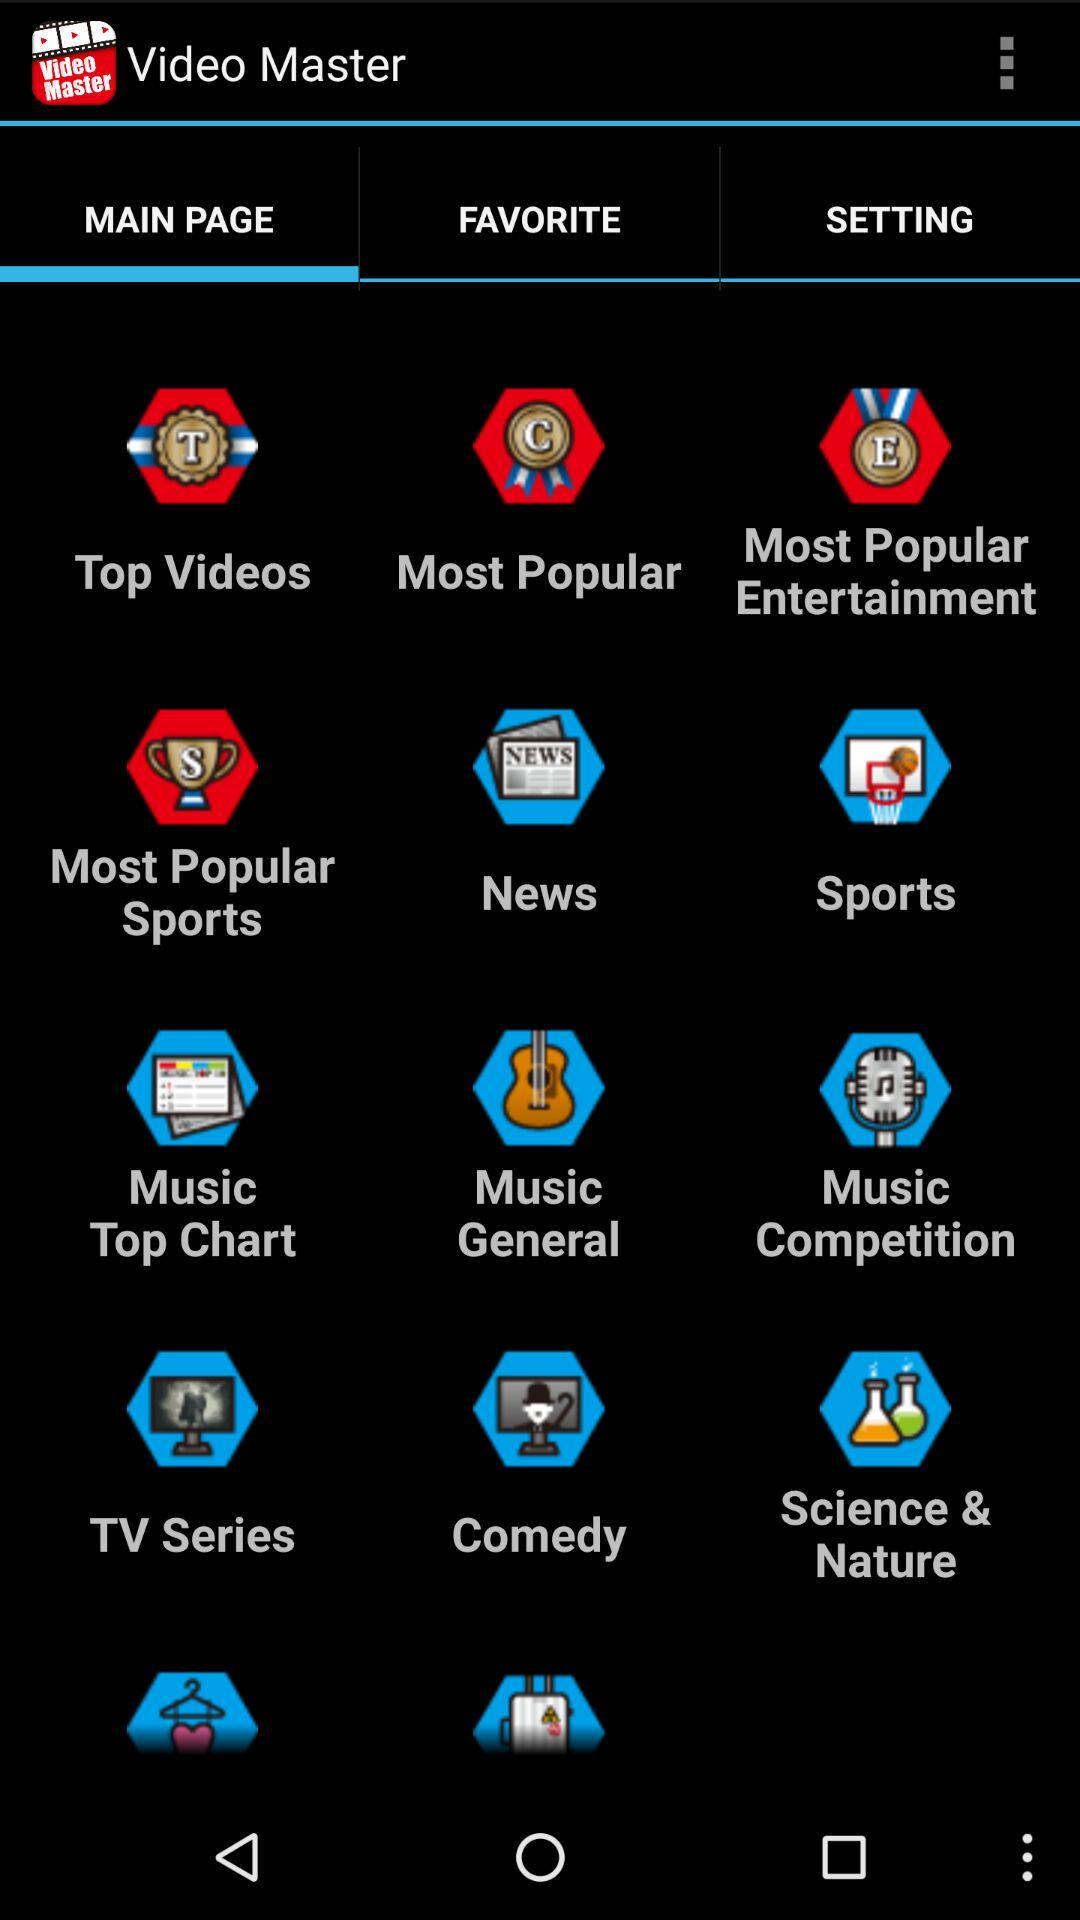Which tab is selected? The selected tab is "MAIN PAGE". 